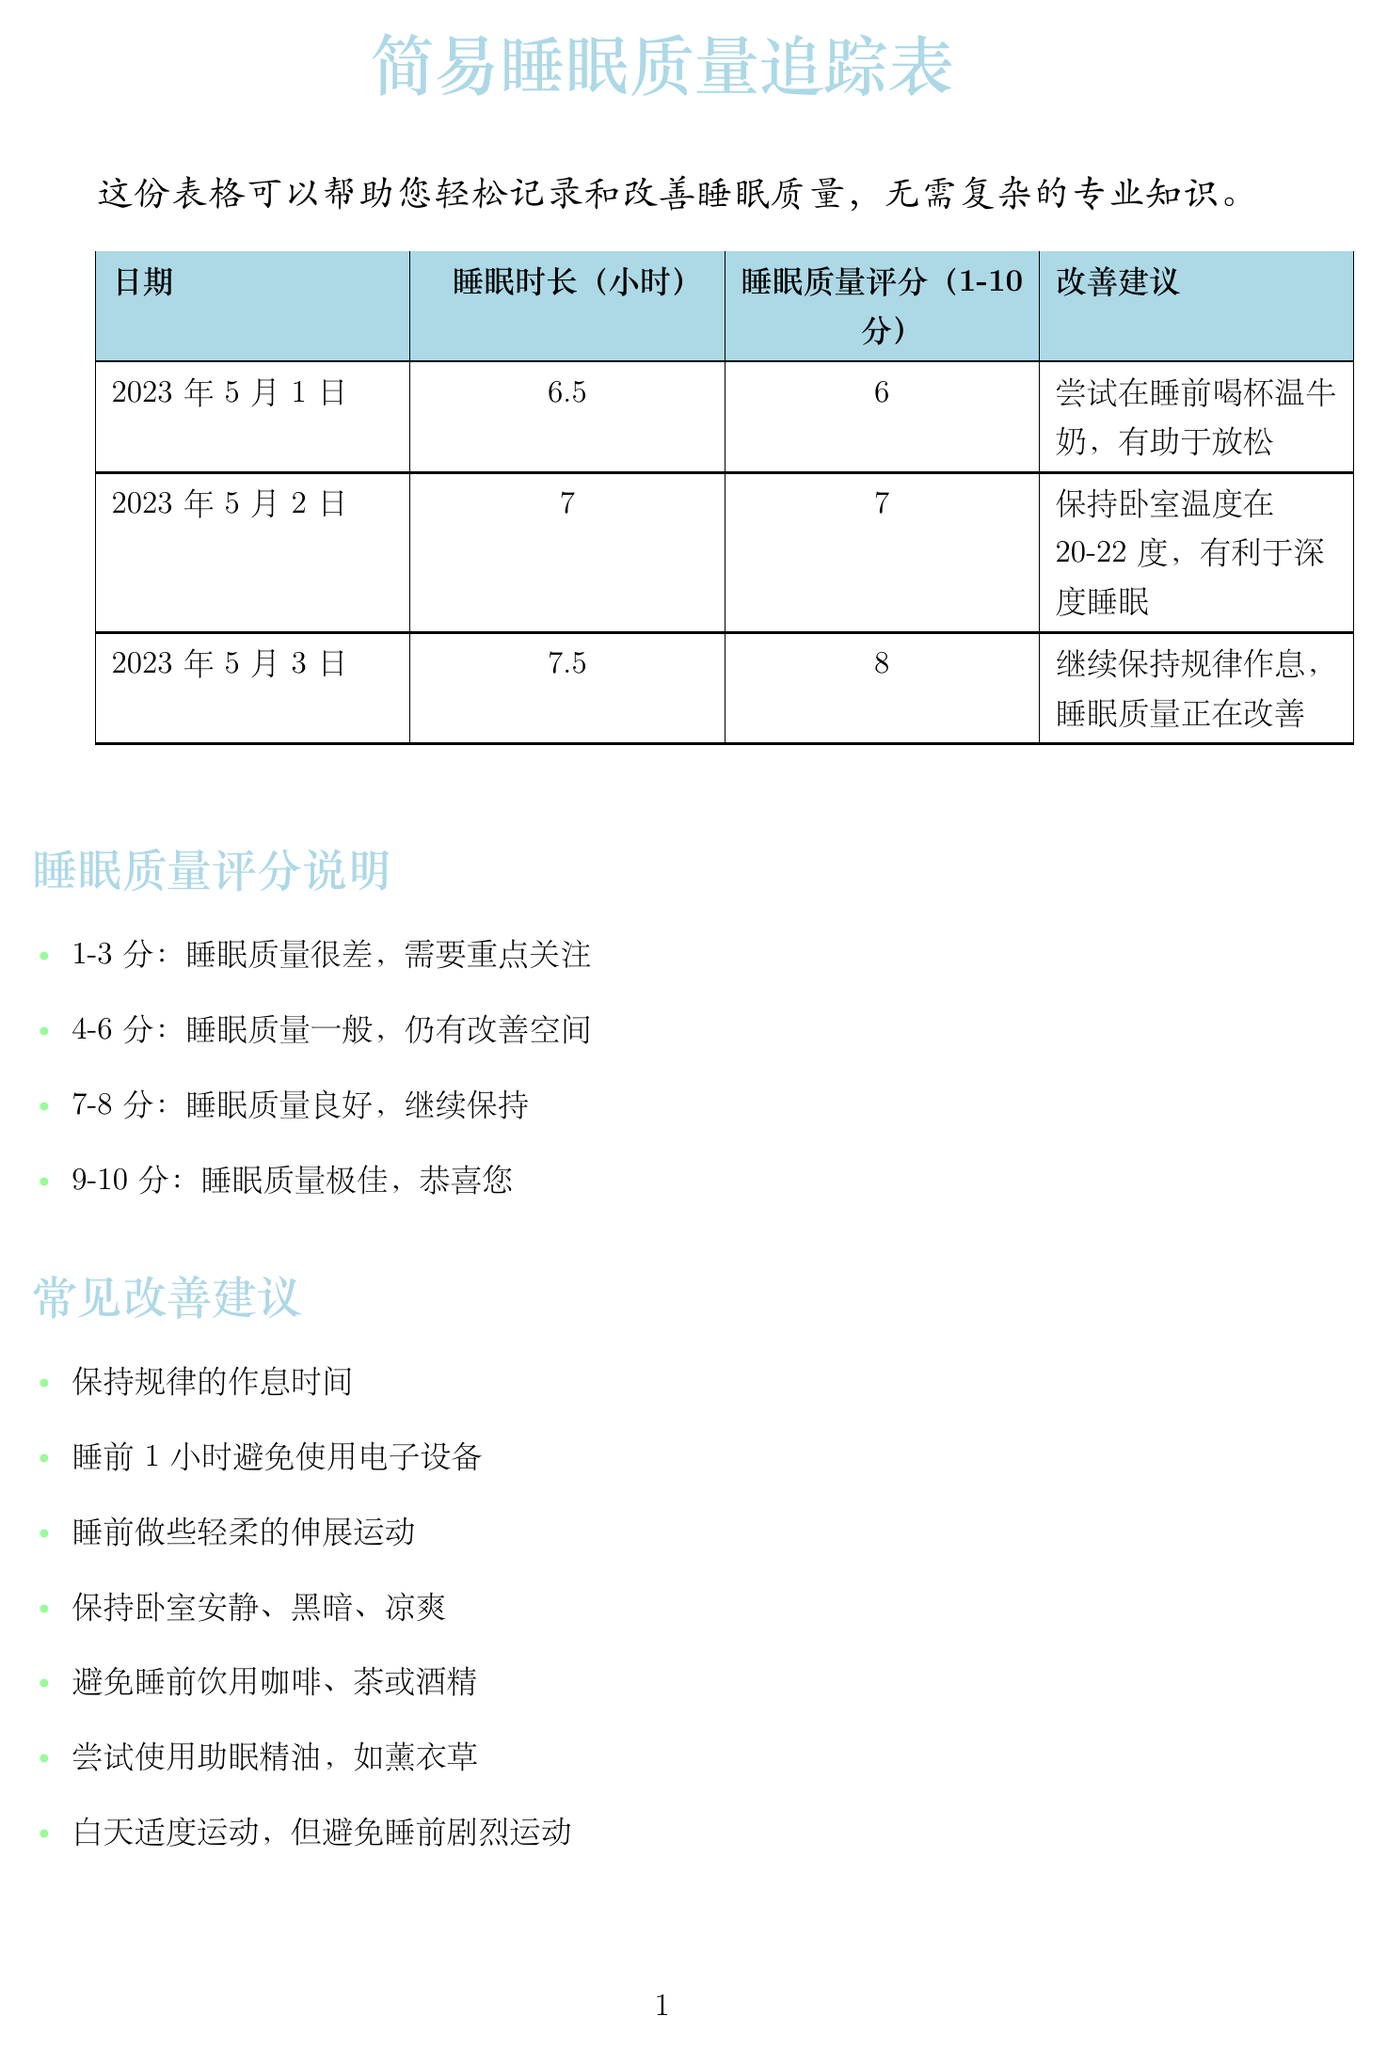什么是表格的标题？ 表格的标题是“简易睡眠质量追踪表”。
Answer: 简易睡眠质量追踪表 这份表格的主要用途是什么？ 说明中提到这份表格可以帮助记录和改善睡眠质量，且无需复杂的专业知识。
Answer: 记录和改善睡眠质量 在2023年5月1日的睡眠质量评分是多少？ 根据示例数据，该日期的睡眠质量评分为6分。
Answer: 6 2023年5月2日的睡眠时长是多少小时？ 表格中显示2023年5月2日的睡眠时长为7小时。
Answer: 7 如果连续一周睡眠质量评分低于多少分，建议咨询医生？ 注意事项中提到连续一周评分低于5分时，建议咨询家庭医生。
Answer: 5分 睡眠质量评分的1-3分表示什么？ 睡眠质量评分说明中提到1-3分表示睡眠质量很差，需要重点关注。
Answer: 睡眠质量很差 什么是改善睡眠质量的建议之一？ 常见改善建议中提到的建议之一是“避免睡前饮用咖啡、茶或酒精”。
Answer: 避免睡前饮用咖啡、茶或酒精 良好的睡眠质量评分范围是多少？ 根据评分说明，良好的睡眠质量评分范围是7-8分。
Answer: 7-8分 